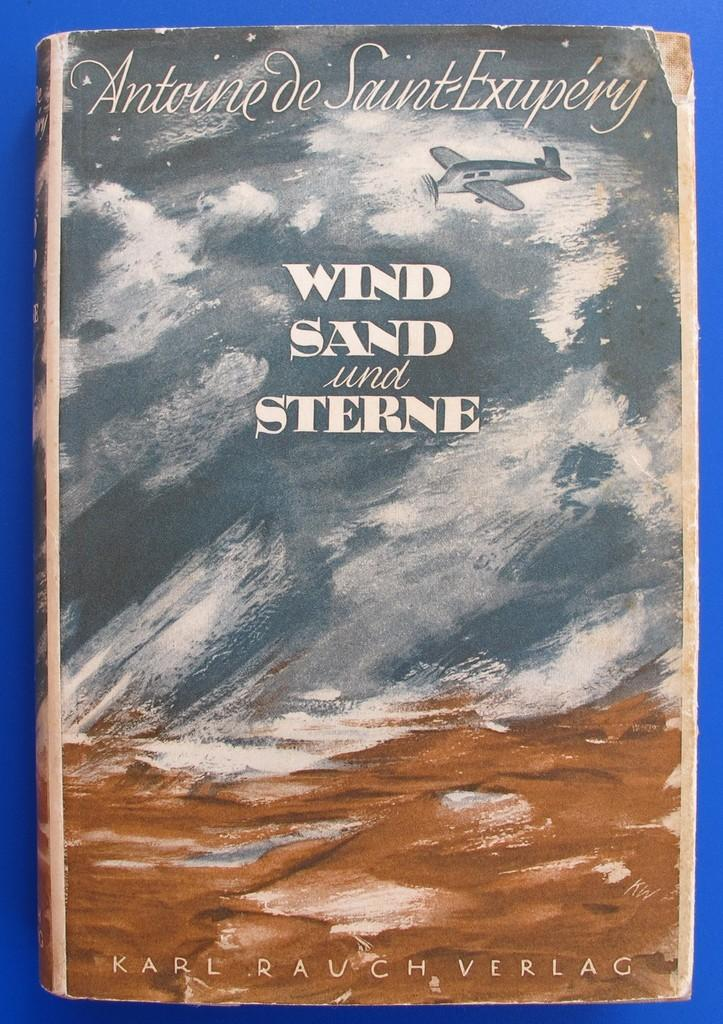<image>
Give a short and clear explanation of the subsequent image. The book Wind Sand and Sterne has a drawing of rough seas and an airplane on its cover. 